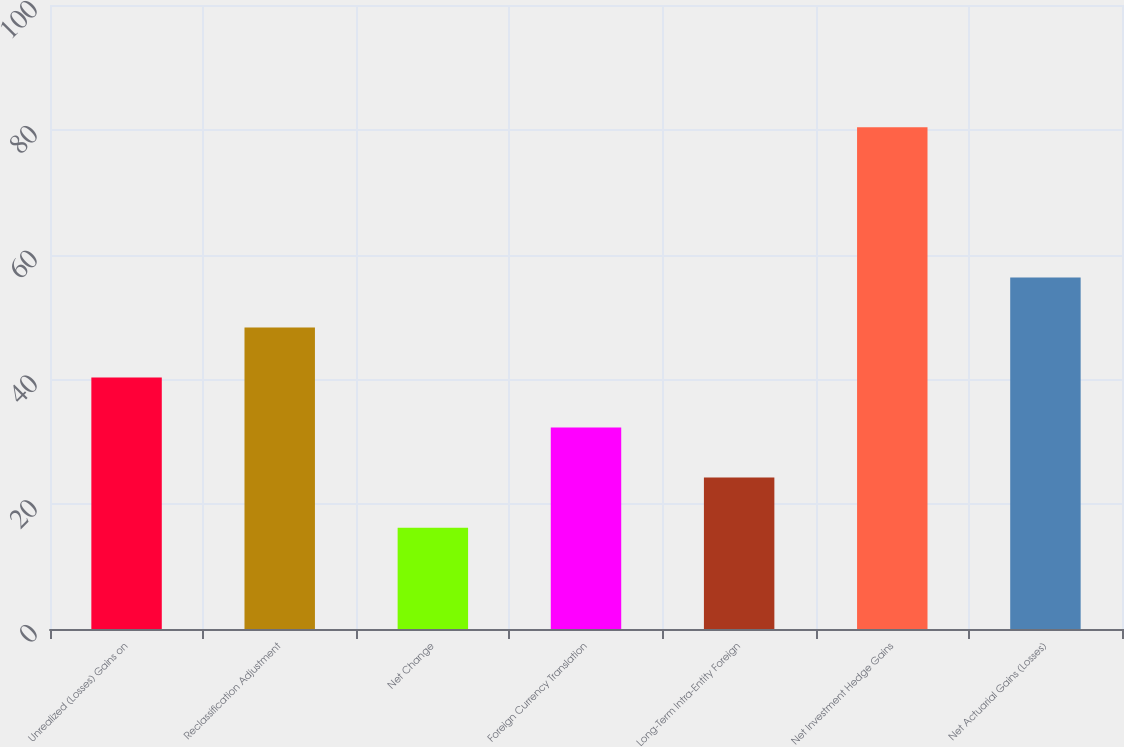<chart> <loc_0><loc_0><loc_500><loc_500><bar_chart><fcel>Unrealized (Losses) Gains on<fcel>Reclassification Adjustment<fcel>Net Change<fcel>Foreign Currency Translation<fcel>Long-Term Intra-Entity Foreign<fcel>Net Investment Hedge Gains<fcel>Net Actuarial Gains (Losses)<nl><fcel>40.3<fcel>48.32<fcel>16.24<fcel>32.28<fcel>24.26<fcel>80.4<fcel>56.34<nl></chart> 